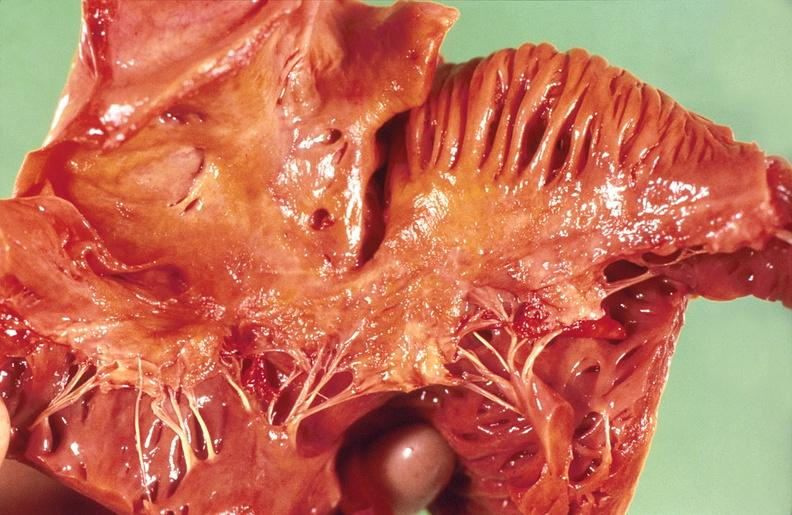s cardiovascular present?
Answer the question using a single word or phrase. Yes 